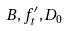Convert formula to latex. <formula><loc_0><loc_0><loc_500><loc_500>B , f _ { t } ^ { \prime } , D _ { 0 }</formula> 